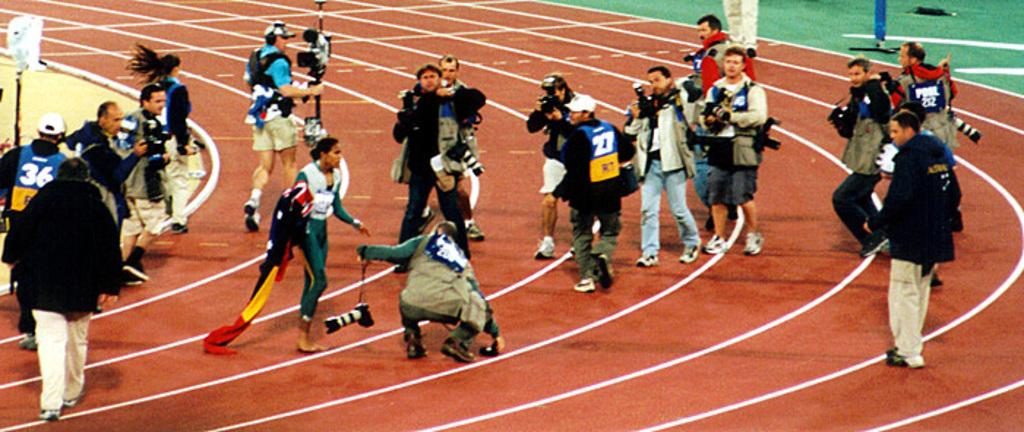What are the people in the image doing? The people in the image are standing in the center and holding objects. What can be seen in the background of the image? There are poles, grass, and other unspecified objects in the background of the image. What type of substance is the throne made of in the image? There is no throne present in the image. What is the opinion of the people in the image about the objects they are holding? The image does not provide any information about the people's opinions regarding the objects they are holding. 